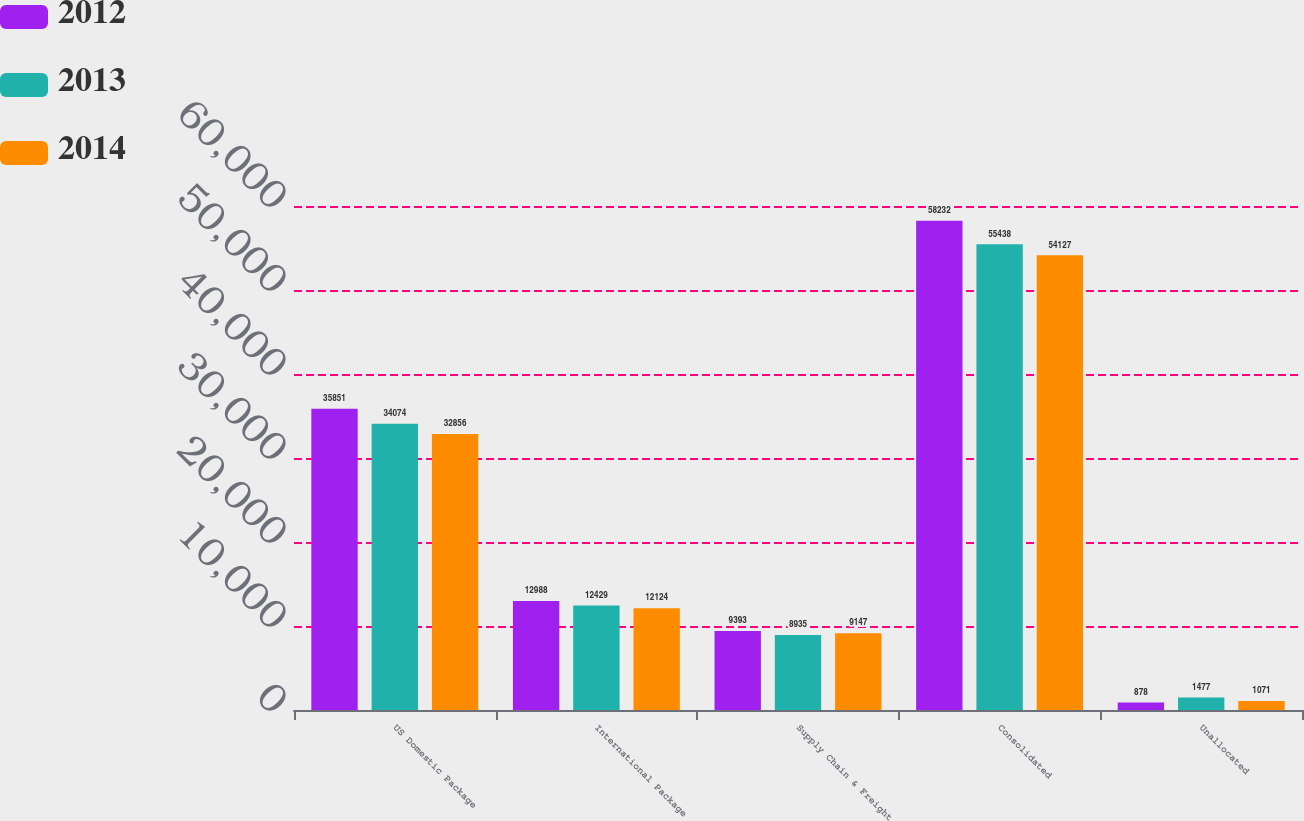<chart> <loc_0><loc_0><loc_500><loc_500><stacked_bar_chart><ecel><fcel>US Domestic Package<fcel>International Package<fcel>Supply Chain & Freight<fcel>Consolidated<fcel>Unallocated<nl><fcel>2012<fcel>35851<fcel>12988<fcel>9393<fcel>58232<fcel>878<nl><fcel>2013<fcel>34074<fcel>12429<fcel>8935<fcel>55438<fcel>1477<nl><fcel>2014<fcel>32856<fcel>12124<fcel>9147<fcel>54127<fcel>1071<nl></chart> 